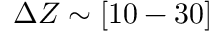Convert formula to latex. <formula><loc_0><loc_0><loc_500><loc_500>\Delta Z \sim [ 1 0 - 3 0 ]</formula> 